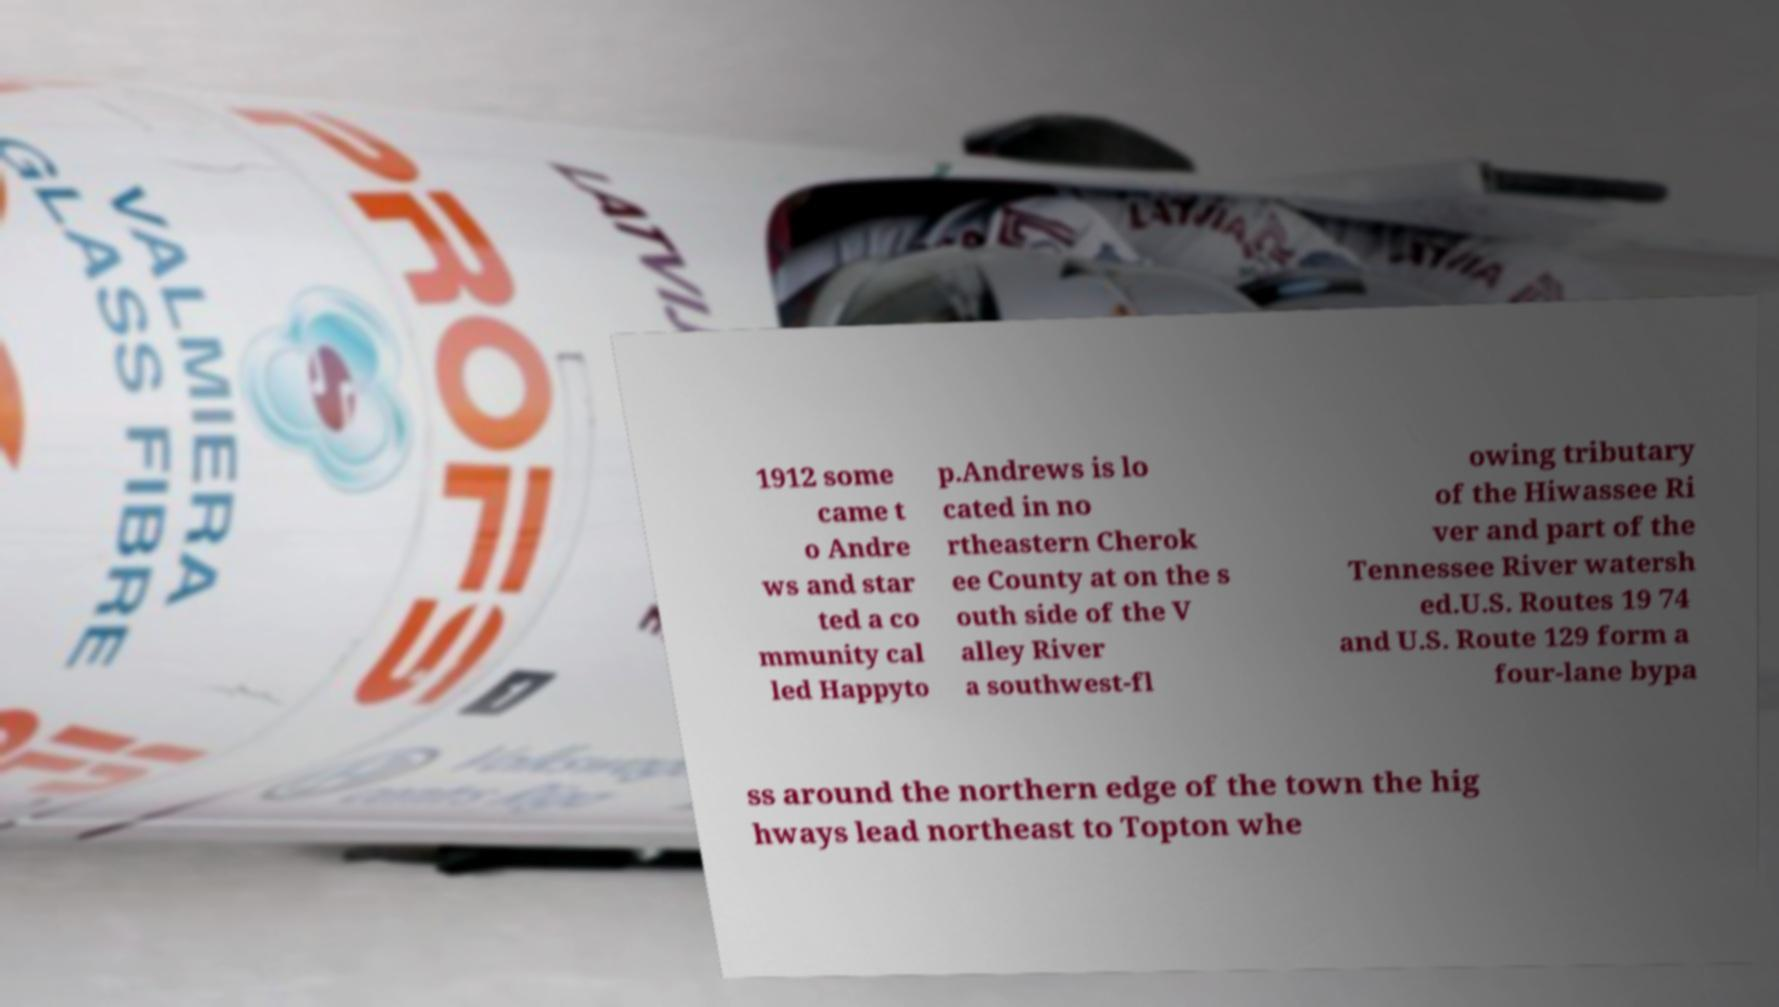I need the written content from this picture converted into text. Can you do that? 1912 some came t o Andre ws and star ted a co mmunity cal led Happyto p.Andrews is lo cated in no rtheastern Cherok ee County at on the s outh side of the V alley River a southwest-fl owing tributary of the Hiwassee Ri ver and part of the Tennessee River watersh ed.U.S. Routes 19 74 and U.S. Route 129 form a four-lane bypa ss around the northern edge of the town the hig hways lead northeast to Topton whe 